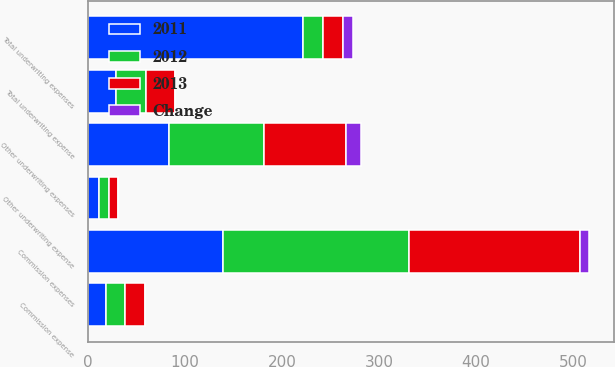Convert chart to OTSL. <chart><loc_0><loc_0><loc_500><loc_500><stacked_bar_chart><ecel><fcel>Commission expenses<fcel>Other underwriting expenses<fcel>Total underwriting expenses<fcel>Commission expense<fcel>Other underwriting expense<fcel>Total underwriting expense<nl><fcel>2012<fcel>192<fcel>98<fcel>20.15<fcel>20<fcel>10.2<fcel>30.2<nl><fcel>2013<fcel>176<fcel>85<fcel>20.15<fcel>20.3<fcel>9.8<fcel>30.1<nl><fcel>2011<fcel>139<fcel>83<fcel>222<fcel>18.2<fcel>10.9<fcel>29.1<nl><fcel>Change<fcel>9<fcel>15<fcel>11<fcel>0.3<fcel>0.4<fcel>0.1<nl></chart> 